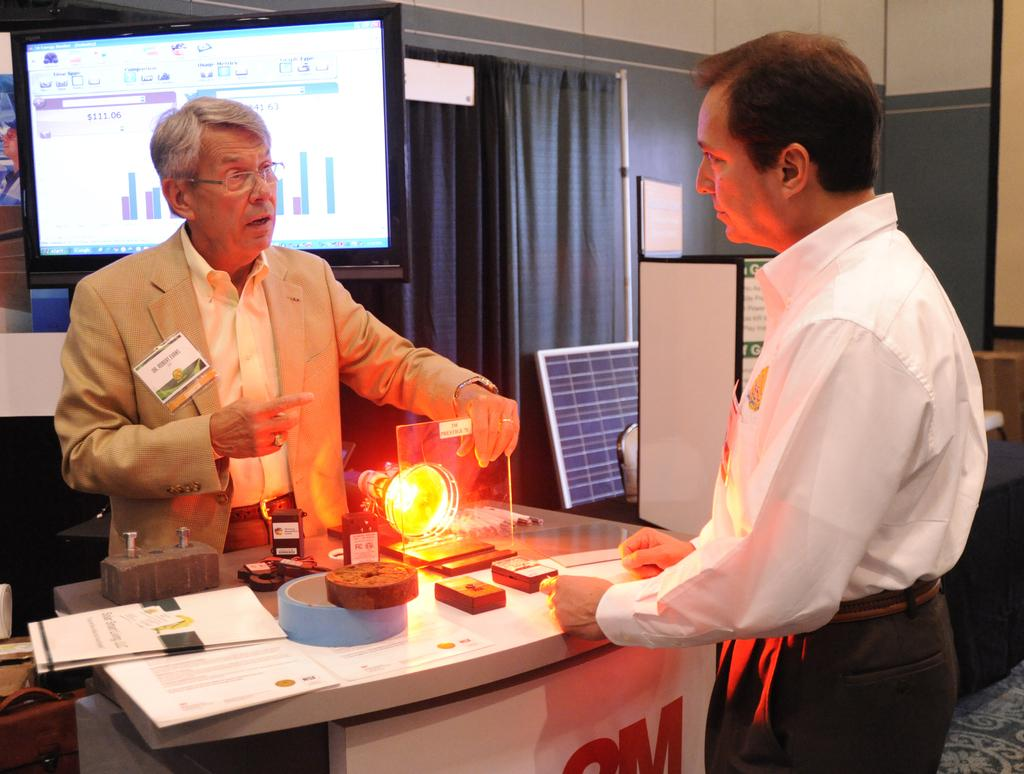What type of window treatment is visible in the image? There are curtains in the image. What type of structure can be seen in the background? There is a wall in the image. What type of display device is present in the image? There is a screen in the image. How many people are present in the image? There are two people standing in the image. What type of furniture is visible in the image? There is a table in the image. What is on the table in the image? There is a light and papers on the table. What type of decoration is present in the image? There is a banner in the image. Can you see any smoke coming from the people in the image? There is no smoke present in the image. What type of body is visible in the image? There are no bodies present in the image, only two people standing. 